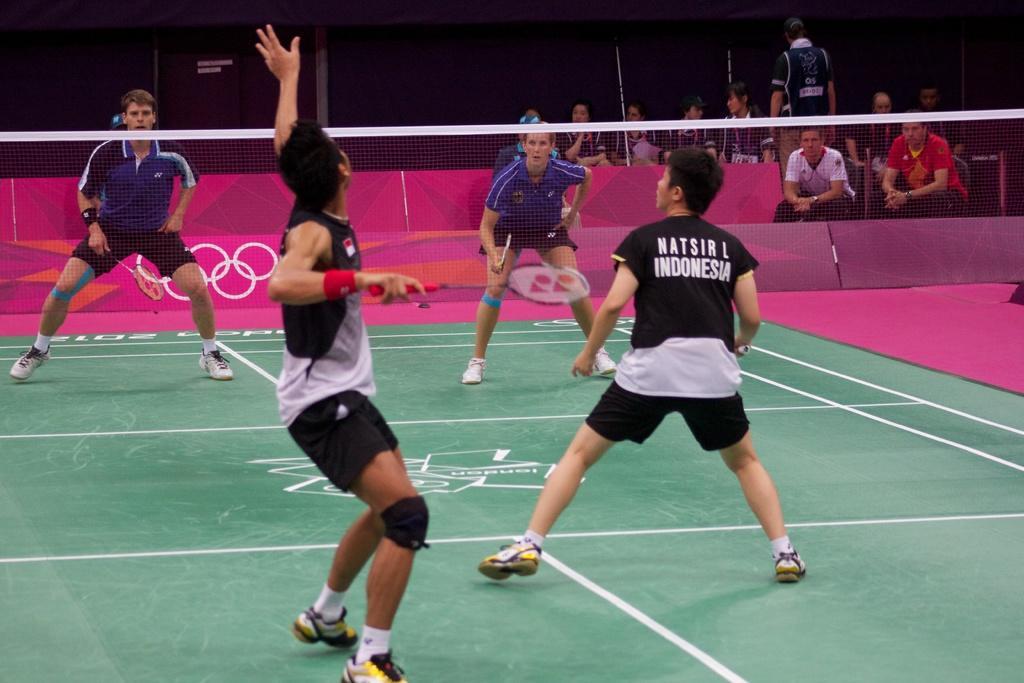Describe this image in one or two sentences. The image is clicked inside a badminton stadium where two people are playing on each side. Here one team is in black color and the other is in blue color. There are even spectators in the background. 